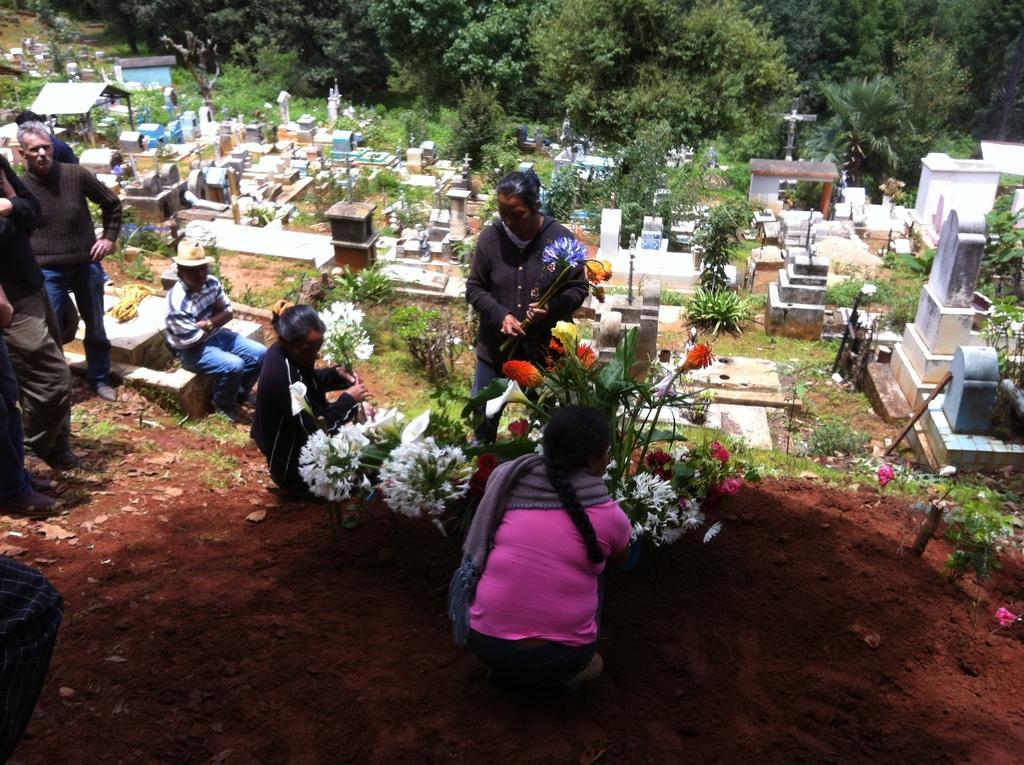Please provide a concise description of this image. In this image, we can see people sitting and standing in the graveyard. We can also see some plants with flowers on it. In the background, we can see some trees. 